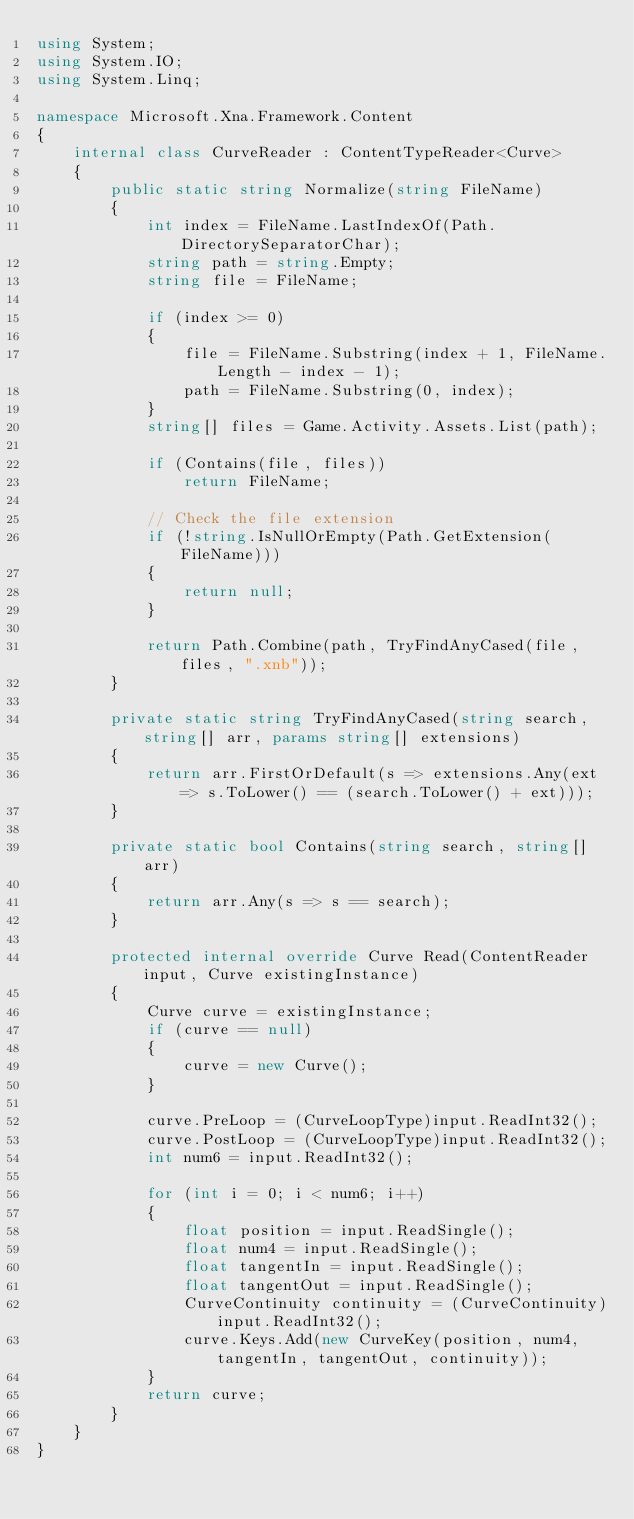Convert code to text. <code><loc_0><loc_0><loc_500><loc_500><_C#_>using System;
using System.IO;
using System.Linq;

namespace Microsoft.Xna.Framework.Content
{
	internal class CurveReader : ContentTypeReader<Curve>
	{
		public static string Normalize(string FileName)
		{
			int index = FileName.LastIndexOf(Path.DirectorySeparatorChar);
			string path = string.Empty;
			string file = FileName;
			
			if (index >= 0)
			{
				file = FileName.Substring(index + 1, FileName.Length - index - 1);
				path = FileName.Substring(0, index);
			}
			string[] files = Game.Activity.Assets.List(path);
			
			if (Contains(file, files))
				return FileName;
			
			// Check the file extension
			if (!string.IsNullOrEmpty(Path.GetExtension(FileName)))
			{
				return null;
			}
			
			return Path.Combine(path, TryFindAnyCased(file, files, ".xnb"));
		}
		
		private static string TryFindAnyCased(string search, string[] arr, params string[] extensions)
		{
			return arr.FirstOrDefault(s => extensions.Any(ext => s.ToLower() == (search.ToLower() + ext)));
		}
		
		private static bool Contains(string search, string[] arr)
		{
			return arr.Any(s => s == search);
		}
		
		protected internal override Curve Read(ContentReader input, Curve existingInstance)
		{
			Curve curve = existingInstance;
			if (curve == null)
			{
				curve = new Curve();
			}         
			
			curve.PreLoop = (CurveLoopType)input.ReadInt32();
			curve.PostLoop = (CurveLoopType)input.ReadInt32();
			int num6 = input.ReadInt32();
			
			for (int i = 0; i < num6; i++)
			{
				float position = input.ReadSingle();
				float num4 = input.ReadSingle();
				float tangentIn = input.ReadSingle();
				float tangentOut = input.ReadSingle();
				CurveContinuity continuity = (CurveContinuity)input.ReadInt32();
				curve.Keys.Add(new CurveKey(position, num4, tangentIn, tangentOut, continuity));
			}		
			return curve;         
		}
	}
}

</code> 